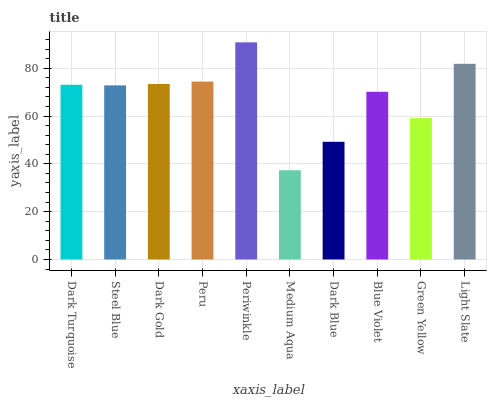Is Medium Aqua the minimum?
Answer yes or no. Yes. Is Periwinkle the maximum?
Answer yes or no. Yes. Is Steel Blue the minimum?
Answer yes or no. No. Is Steel Blue the maximum?
Answer yes or no. No. Is Dark Turquoise greater than Steel Blue?
Answer yes or no. Yes. Is Steel Blue less than Dark Turquoise?
Answer yes or no. Yes. Is Steel Blue greater than Dark Turquoise?
Answer yes or no. No. Is Dark Turquoise less than Steel Blue?
Answer yes or no. No. Is Dark Turquoise the high median?
Answer yes or no. Yes. Is Steel Blue the low median?
Answer yes or no. Yes. Is Peru the high median?
Answer yes or no. No. Is Periwinkle the low median?
Answer yes or no. No. 